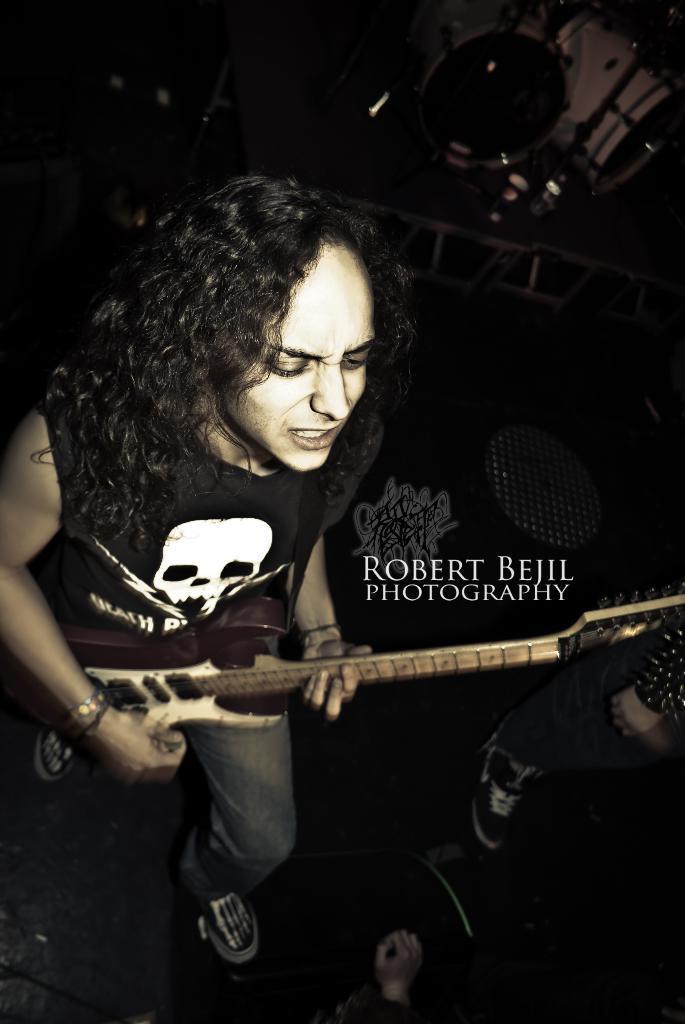Could you give a brief overview of what you see in this image? in this image there is a person playing guitar. he is wearing black t shirt, skull printed on it and jeans. right to him a person's leg is appearing. behind them there are drums. 